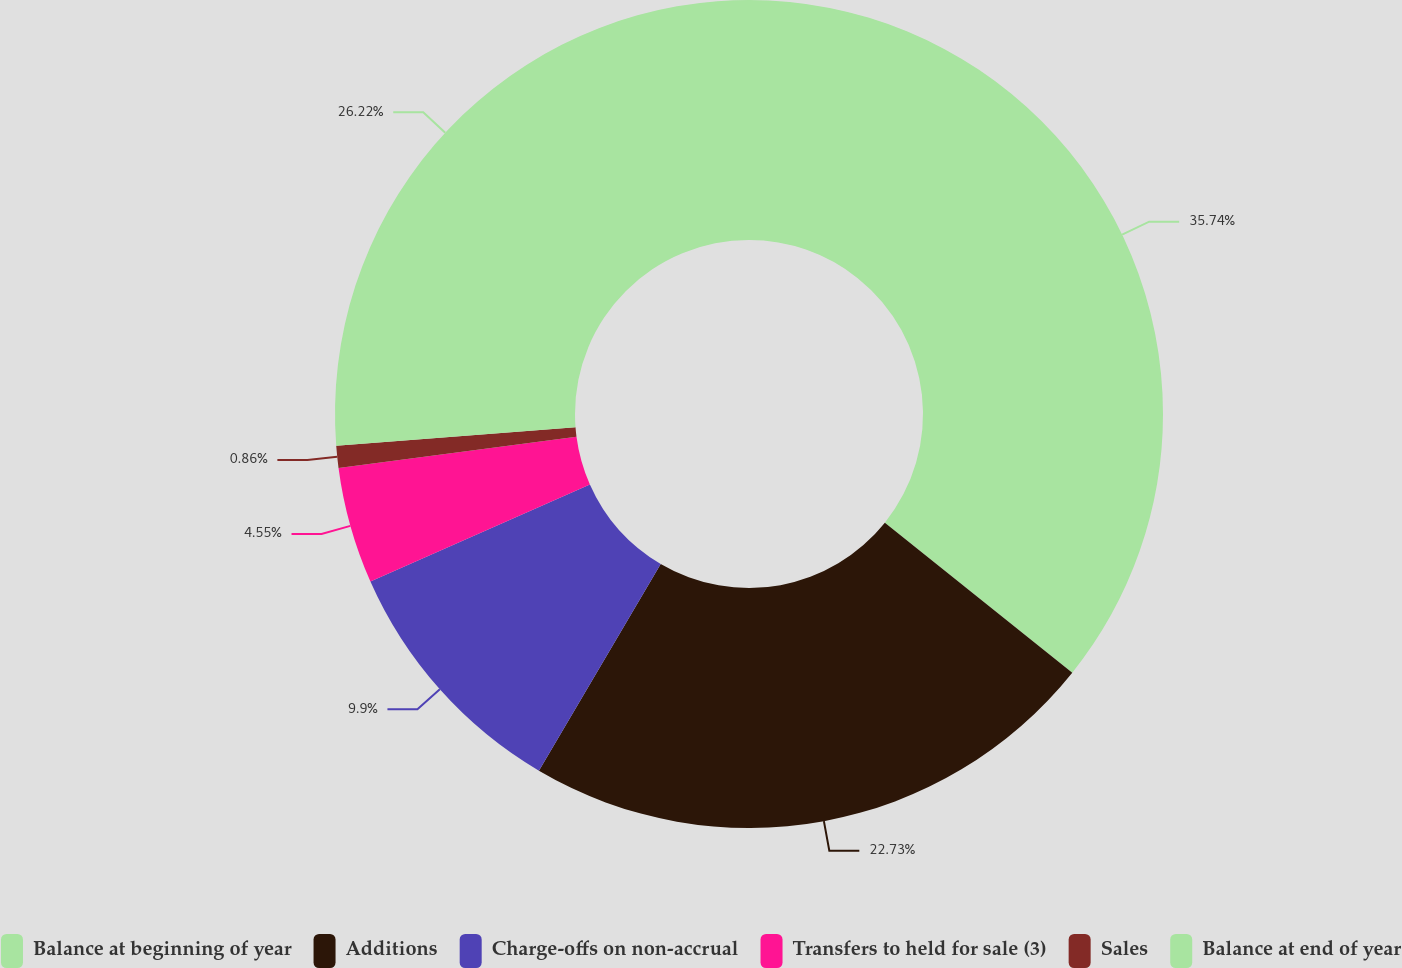<chart> <loc_0><loc_0><loc_500><loc_500><pie_chart><fcel>Balance at beginning of year<fcel>Additions<fcel>Charge-offs on non-accrual<fcel>Transfers to held for sale (3)<fcel>Sales<fcel>Balance at end of year<nl><fcel>35.74%<fcel>22.73%<fcel>9.9%<fcel>4.55%<fcel>0.86%<fcel>26.22%<nl></chart> 